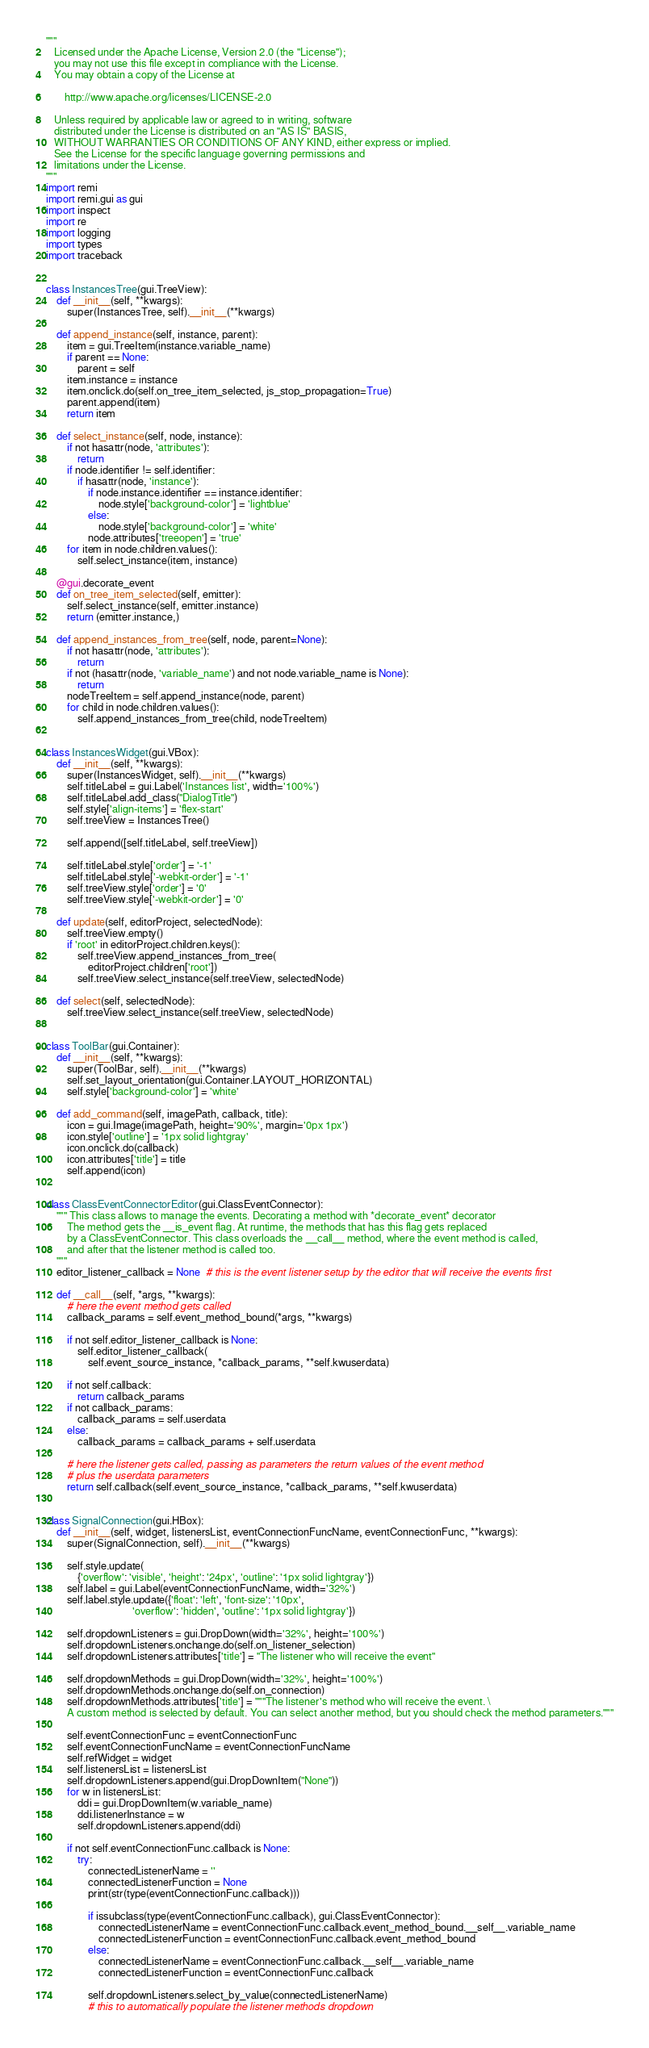<code> <loc_0><loc_0><loc_500><loc_500><_Python_>"""
   Licensed under the Apache License, Version 2.0 (the "License");
   you may not use this file except in compliance with the License.
   You may obtain a copy of the License at

       http://www.apache.org/licenses/LICENSE-2.0

   Unless required by applicable law or agreed to in writing, software
   distributed under the License is distributed on an "AS IS" BASIS,
   WITHOUT WARRANTIES OR CONDITIONS OF ANY KIND, either express or implied.
   See the License for the specific language governing permissions and
   limitations under the License.
"""
import remi
import remi.gui as gui
import inspect
import re
import logging
import types
import traceback


class InstancesTree(gui.TreeView):
    def __init__(self, **kwargs):
        super(InstancesTree, self).__init__(**kwargs)

    def append_instance(self, instance, parent):
        item = gui.TreeItem(instance.variable_name)
        if parent == None:
            parent = self
        item.instance = instance
        item.onclick.do(self.on_tree_item_selected, js_stop_propagation=True)
        parent.append(item)
        return item

    def select_instance(self, node, instance):
        if not hasattr(node, 'attributes'):
            return
        if node.identifier != self.identifier:
            if hasattr(node, 'instance'):
                if node.instance.identifier == instance.identifier:
                    node.style['background-color'] = 'lightblue'
                else:
                    node.style['background-color'] = 'white'
                node.attributes['treeopen'] = 'true'
        for item in node.children.values():
            self.select_instance(item, instance)

    @gui.decorate_event
    def on_tree_item_selected(self, emitter):
        self.select_instance(self, emitter.instance)
        return (emitter.instance,)

    def append_instances_from_tree(self, node, parent=None):
        if not hasattr(node, 'attributes'):
            return
        if not (hasattr(node, 'variable_name') and not node.variable_name is None):
            return
        nodeTreeItem = self.append_instance(node, parent)
        for child in node.children.values():
            self.append_instances_from_tree(child, nodeTreeItem)


class InstancesWidget(gui.VBox):
    def __init__(self, **kwargs):
        super(InstancesWidget, self).__init__(**kwargs)
        self.titleLabel = gui.Label('Instances list', width='100%')
        self.titleLabel.add_class("DialogTitle")
        self.style['align-items'] = 'flex-start'
        self.treeView = InstancesTree()

        self.append([self.titleLabel, self.treeView])

        self.titleLabel.style['order'] = '-1'
        self.titleLabel.style['-webkit-order'] = '-1'
        self.treeView.style['order'] = '0'
        self.treeView.style['-webkit-order'] = '0'

    def update(self, editorProject, selectedNode):
        self.treeView.empty()
        if 'root' in editorProject.children.keys():
            self.treeView.append_instances_from_tree(
                editorProject.children['root'])
            self.treeView.select_instance(self.treeView, selectedNode)

    def select(self, selectedNode):
        self.treeView.select_instance(self.treeView, selectedNode)


class ToolBar(gui.Container):
    def __init__(self, **kwargs):
        super(ToolBar, self).__init__(**kwargs)
        self.set_layout_orientation(gui.Container.LAYOUT_HORIZONTAL)
        self.style['background-color'] = 'white'

    def add_command(self, imagePath, callback, title):
        icon = gui.Image(imagePath, height='90%', margin='0px 1px')
        icon.style['outline'] = '1px solid lightgray'
        icon.onclick.do(callback)
        icon.attributes['title'] = title
        self.append(icon)


class ClassEventConnectorEditor(gui.ClassEventConnector):
    """ This class allows to manage the events. Decorating a method with *decorate_event* decorator
        The method gets the __is_event flag. At runtime, the methods that has this flag gets replaced
        by a ClassEventConnector. This class overloads the __call__ method, where the event method is called,
        and after that the listener method is called too.
    """
    editor_listener_callback = None  # this is the event listener setup by the editor that will receive the events first

    def __call__(self, *args, **kwargs):
        # here the event method gets called
        callback_params = self.event_method_bound(*args, **kwargs)

        if not self.editor_listener_callback is None:
            self.editor_listener_callback(
                self.event_source_instance, *callback_params, **self.kwuserdata)

        if not self.callback:
            return callback_params
        if not callback_params:
            callback_params = self.userdata
        else:
            callback_params = callback_params + self.userdata

        # here the listener gets called, passing as parameters the return values of the event method
        # plus the userdata parameters
        return self.callback(self.event_source_instance, *callback_params, **self.kwuserdata)


class SignalConnection(gui.HBox):
    def __init__(self, widget, listenersList, eventConnectionFuncName, eventConnectionFunc, **kwargs):
        super(SignalConnection, self).__init__(**kwargs)

        self.style.update(
            {'overflow': 'visible', 'height': '24px', 'outline': '1px solid lightgray'})
        self.label = gui.Label(eventConnectionFuncName, width='32%')
        self.label.style.update({'float': 'left', 'font-size': '10px',
                                 'overflow': 'hidden', 'outline': '1px solid lightgray'})

        self.dropdownListeners = gui.DropDown(width='32%', height='100%')
        self.dropdownListeners.onchange.do(self.on_listener_selection)
        self.dropdownListeners.attributes['title'] = "The listener who will receive the event"

        self.dropdownMethods = gui.DropDown(width='32%', height='100%')
        self.dropdownMethods.onchange.do(self.on_connection)
        self.dropdownMethods.attributes['title'] = """The listener's method who will receive the event. \
        A custom method is selected by default. You can select another method, but you should check the method parameters."""

        self.eventConnectionFunc = eventConnectionFunc
        self.eventConnectionFuncName = eventConnectionFuncName
        self.refWidget = widget
        self.listenersList = listenersList
        self.dropdownListeners.append(gui.DropDownItem("None"))
        for w in listenersList:
            ddi = gui.DropDownItem(w.variable_name)
            ddi.listenerInstance = w
            self.dropdownListeners.append(ddi)

        if not self.eventConnectionFunc.callback is None:
            try:
                connectedListenerName = ''
                connectedListenerFunction = None
                print(str(type(eventConnectionFunc.callback)))

                if issubclass(type(eventConnectionFunc.callback), gui.ClassEventConnector):
                    connectedListenerName = eventConnectionFunc.callback.event_method_bound.__self__.variable_name
                    connectedListenerFunction = eventConnectionFunc.callback.event_method_bound
                else:
                    connectedListenerName = eventConnectionFunc.callback.__self__.variable_name
                    connectedListenerFunction = eventConnectionFunc.callback

                self.dropdownListeners.select_by_value(connectedListenerName)
                # this to automatically populate the listener methods dropdown
</code> 